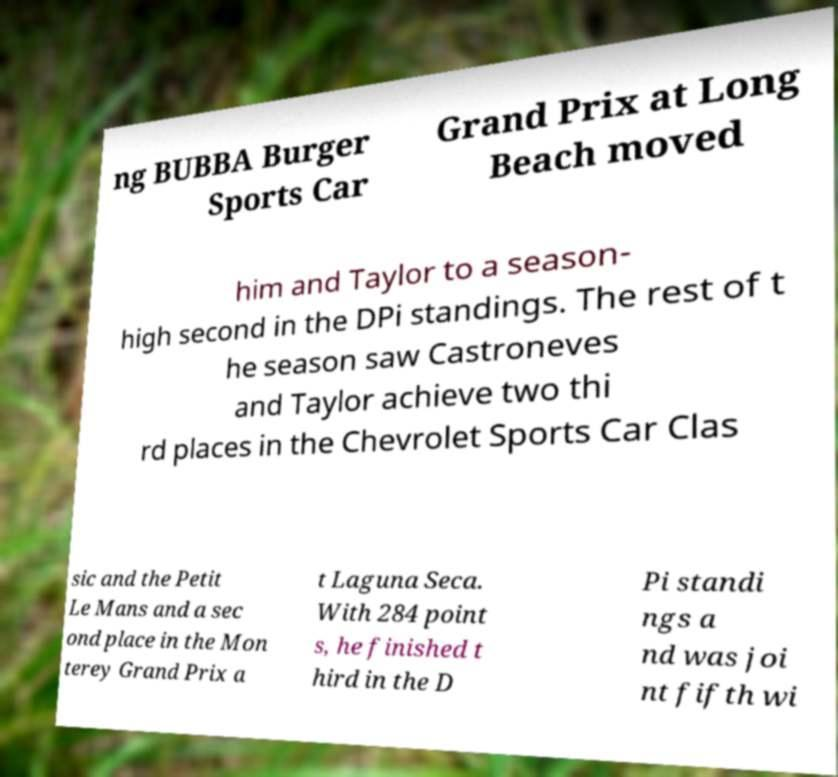There's text embedded in this image that I need extracted. Can you transcribe it verbatim? ng BUBBA Burger Sports Car Grand Prix at Long Beach moved him and Taylor to a season- high second in the DPi standings. The rest of t he season saw Castroneves and Taylor achieve two thi rd places in the Chevrolet Sports Car Clas sic and the Petit Le Mans and a sec ond place in the Mon terey Grand Prix a t Laguna Seca. With 284 point s, he finished t hird in the D Pi standi ngs a nd was joi nt fifth wi 